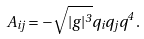Convert formula to latex. <formula><loc_0><loc_0><loc_500><loc_500>A _ { i j } = - \sqrt { | g | ^ { 3 } } q _ { i } q _ { j } q ^ { 4 } \, .</formula> 